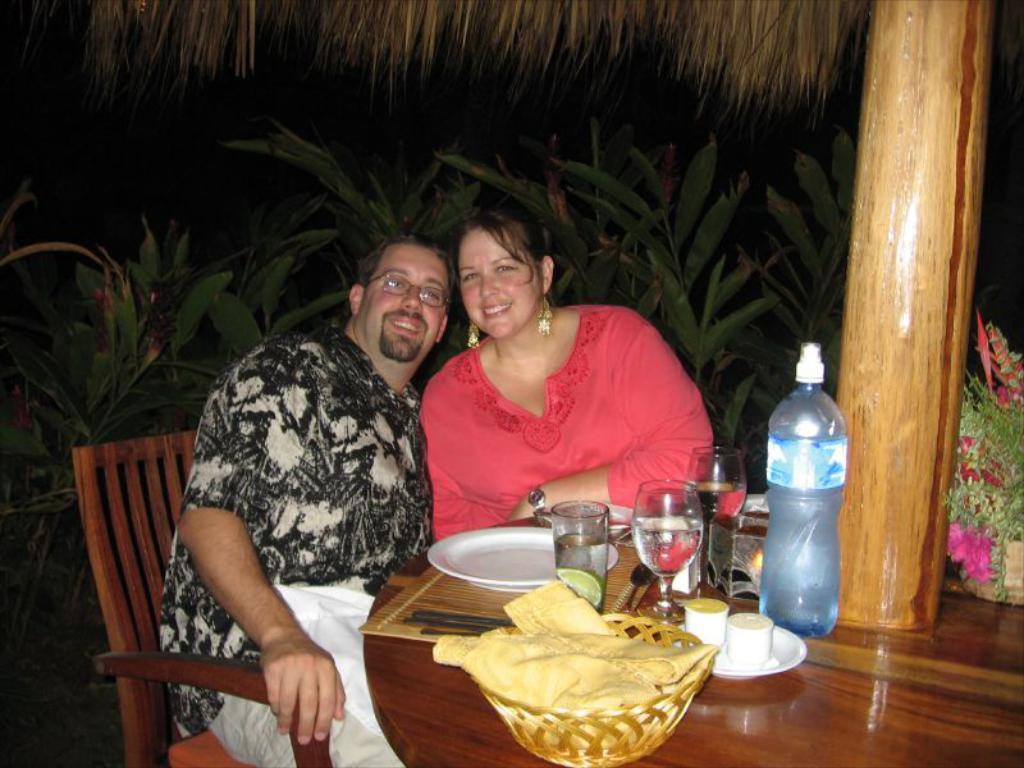Could you give a brief overview of what you see in this image? In this image there is a man and woman sitting in a chair and in table there is napkin, bowl, cup, saucer, bottle, glass, plate, small plant in a table and the back ground there are plants and tree. 